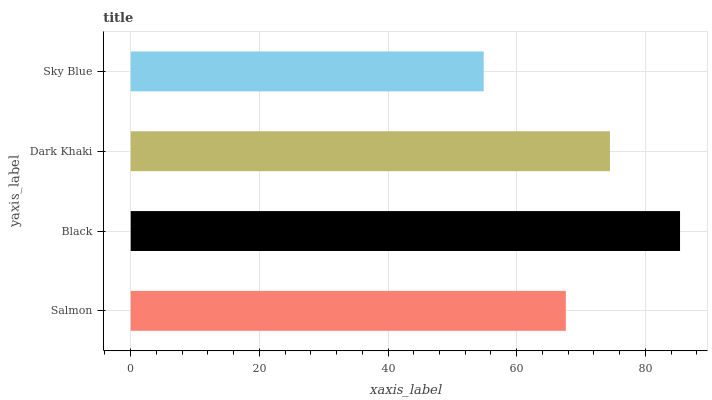Is Sky Blue the minimum?
Answer yes or no. Yes. Is Black the maximum?
Answer yes or no. Yes. Is Dark Khaki the minimum?
Answer yes or no. No. Is Dark Khaki the maximum?
Answer yes or no. No. Is Black greater than Dark Khaki?
Answer yes or no. Yes. Is Dark Khaki less than Black?
Answer yes or no. Yes. Is Dark Khaki greater than Black?
Answer yes or no. No. Is Black less than Dark Khaki?
Answer yes or no. No. Is Dark Khaki the high median?
Answer yes or no. Yes. Is Salmon the low median?
Answer yes or no. Yes. Is Salmon the high median?
Answer yes or no. No. Is Dark Khaki the low median?
Answer yes or no. No. 